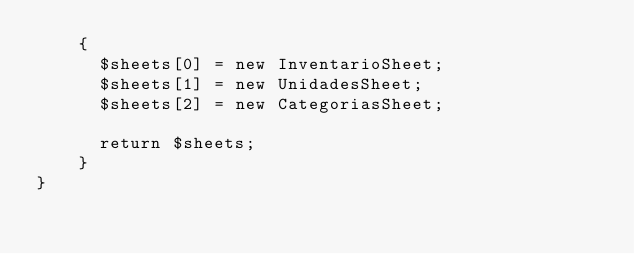Convert code to text. <code><loc_0><loc_0><loc_500><loc_500><_PHP_>    {
      $sheets[0] = new InventarioSheet;
      $sheets[1] = new UnidadesSheet;
      $sheets[2] = new CategoriasSheet;

      return $sheets;
    }
}
</code> 